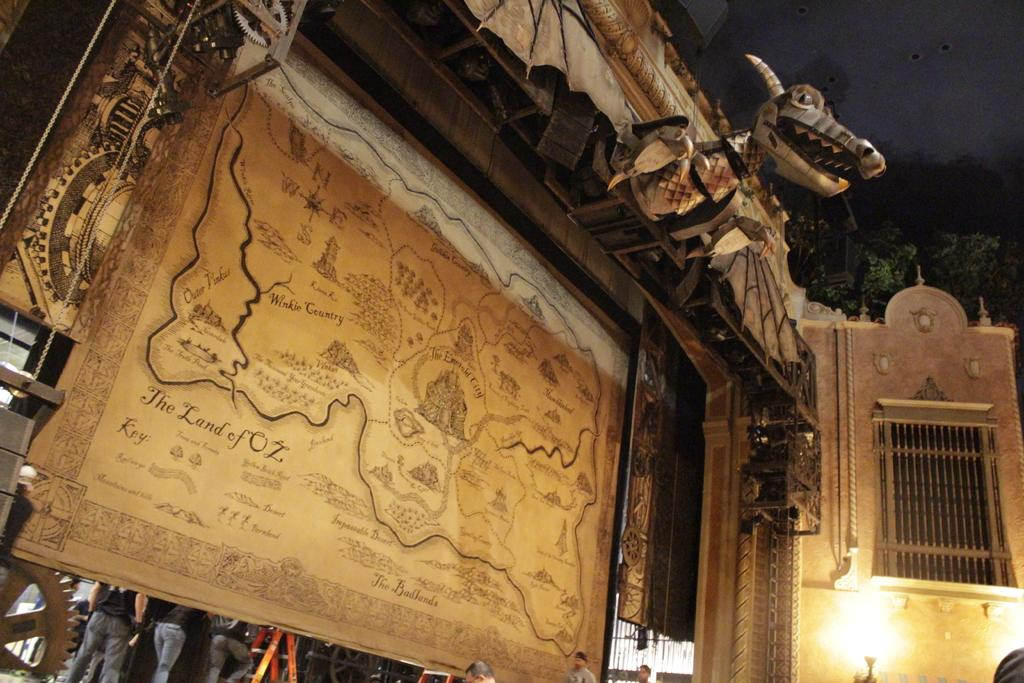What is the main object in the image? There is a wooden block with a map in the image. What can be seen under the wooden block? There are people standing under the wooden block. What type of drum is being played by the people under the wooden block? There is no drum present in the image; the people are standing under the wooden block with a map. 